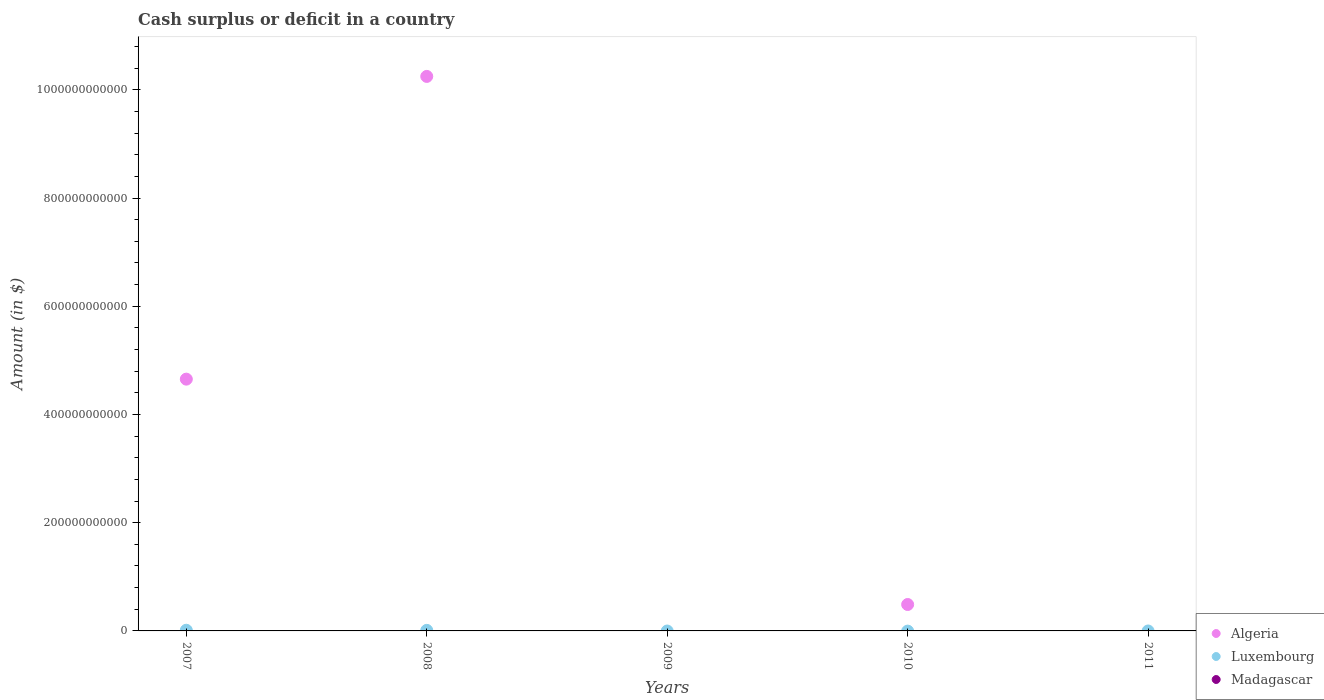Is the number of dotlines equal to the number of legend labels?
Provide a succinct answer. No. Across all years, what is the maximum amount of cash surplus or deficit in Luxembourg?
Keep it short and to the point. 1.24e+09. In which year was the amount of cash surplus or deficit in Algeria maximum?
Offer a very short reply. 2008. What is the total amount of cash surplus or deficit in Algeria in the graph?
Offer a very short reply. 1.54e+12. What is the difference between the amount of cash surplus or deficit in Algeria in 2008 and that in 2010?
Provide a short and direct response. 9.76e+11. What is the difference between the amount of cash surplus or deficit in Luxembourg in 2009 and the amount of cash surplus or deficit in Algeria in 2007?
Make the answer very short. -4.65e+11. In the year 2008, what is the difference between the amount of cash surplus or deficit in Algeria and amount of cash surplus or deficit in Luxembourg?
Your answer should be very brief. 1.02e+12. In how many years, is the amount of cash surplus or deficit in Luxembourg greater than 280000000000 $?
Provide a succinct answer. 0. What is the ratio of the amount of cash surplus or deficit in Algeria in 2007 to that in 2008?
Offer a terse response. 0.45. What is the difference between the highest and the second highest amount of cash surplus or deficit in Algeria?
Ensure brevity in your answer.  5.59e+11. What is the difference between the highest and the lowest amount of cash surplus or deficit in Luxembourg?
Keep it short and to the point. 1.24e+09. In how many years, is the amount of cash surplus or deficit in Madagascar greater than the average amount of cash surplus or deficit in Madagascar taken over all years?
Provide a short and direct response. 0. How many dotlines are there?
Give a very brief answer. 2. How many years are there in the graph?
Keep it short and to the point. 5. What is the difference between two consecutive major ticks on the Y-axis?
Make the answer very short. 2.00e+11. Does the graph contain any zero values?
Offer a terse response. Yes. Where does the legend appear in the graph?
Make the answer very short. Bottom right. How are the legend labels stacked?
Your answer should be very brief. Vertical. What is the title of the graph?
Offer a terse response. Cash surplus or deficit in a country. Does "South Africa" appear as one of the legend labels in the graph?
Make the answer very short. No. What is the label or title of the X-axis?
Provide a succinct answer. Years. What is the label or title of the Y-axis?
Keep it short and to the point. Amount (in $). What is the Amount (in $) of Algeria in 2007?
Provide a short and direct response. 4.65e+11. What is the Amount (in $) of Luxembourg in 2007?
Keep it short and to the point. 1.24e+09. What is the Amount (in $) of Algeria in 2008?
Your response must be concise. 1.02e+12. What is the Amount (in $) of Luxembourg in 2008?
Provide a succinct answer. 1.02e+09. What is the Amount (in $) in Algeria in 2009?
Ensure brevity in your answer.  0. What is the Amount (in $) of Madagascar in 2009?
Give a very brief answer. 0. What is the Amount (in $) in Algeria in 2010?
Your answer should be compact. 4.88e+1. What is the Amount (in $) of Luxembourg in 2010?
Provide a succinct answer. 0. What is the Amount (in $) of Madagascar in 2010?
Offer a very short reply. 0. What is the Amount (in $) in Algeria in 2011?
Your answer should be very brief. 0. Across all years, what is the maximum Amount (in $) in Algeria?
Offer a terse response. 1.02e+12. Across all years, what is the maximum Amount (in $) in Luxembourg?
Offer a terse response. 1.24e+09. What is the total Amount (in $) in Algeria in the graph?
Ensure brevity in your answer.  1.54e+12. What is the total Amount (in $) in Luxembourg in the graph?
Provide a succinct answer. 2.26e+09. What is the total Amount (in $) of Madagascar in the graph?
Your answer should be compact. 0. What is the difference between the Amount (in $) of Algeria in 2007 and that in 2008?
Offer a very short reply. -5.59e+11. What is the difference between the Amount (in $) of Luxembourg in 2007 and that in 2008?
Offer a very short reply. 2.20e+08. What is the difference between the Amount (in $) of Algeria in 2007 and that in 2010?
Keep it short and to the point. 4.16e+11. What is the difference between the Amount (in $) in Algeria in 2008 and that in 2010?
Make the answer very short. 9.76e+11. What is the difference between the Amount (in $) in Algeria in 2007 and the Amount (in $) in Luxembourg in 2008?
Provide a short and direct response. 4.64e+11. What is the average Amount (in $) in Algeria per year?
Your answer should be very brief. 3.08e+11. What is the average Amount (in $) of Luxembourg per year?
Offer a very short reply. 4.53e+08. In the year 2007, what is the difference between the Amount (in $) in Algeria and Amount (in $) in Luxembourg?
Keep it short and to the point. 4.64e+11. In the year 2008, what is the difference between the Amount (in $) of Algeria and Amount (in $) of Luxembourg?
Ensure brevity in your answer.  1.02e+12. What is the ratio of the Amount (in $) in Algeria in 2007 to that in 2008?
Give a very brief answer. 0.45. What is the ratio of the Amount (in $) in Luxembourg in 2007 to that in 2008?
Make the answer very short. 1.22. What is the ratio of the Amount (in $) of Algeria in 2007 to that in 2010?
Your response must be concise. 9.53. What is the ratio of the Amount (in $) in Algeria in 2008 to that in 2010?
Provide a succinct answer. 20.99. What is the difference between the highest and the second highest Amount (in $) in Algeria?
Keep it short and to the point. 5.59e+11. What is the difference between the highest and the lowest Amount (in $) of Algeria?
Give a very brief answer. 1.02e+12. What is the difference between the highest and the lowest Amount (in $) of Luxembourg?
Offer a terse response. 1.24e+09. 